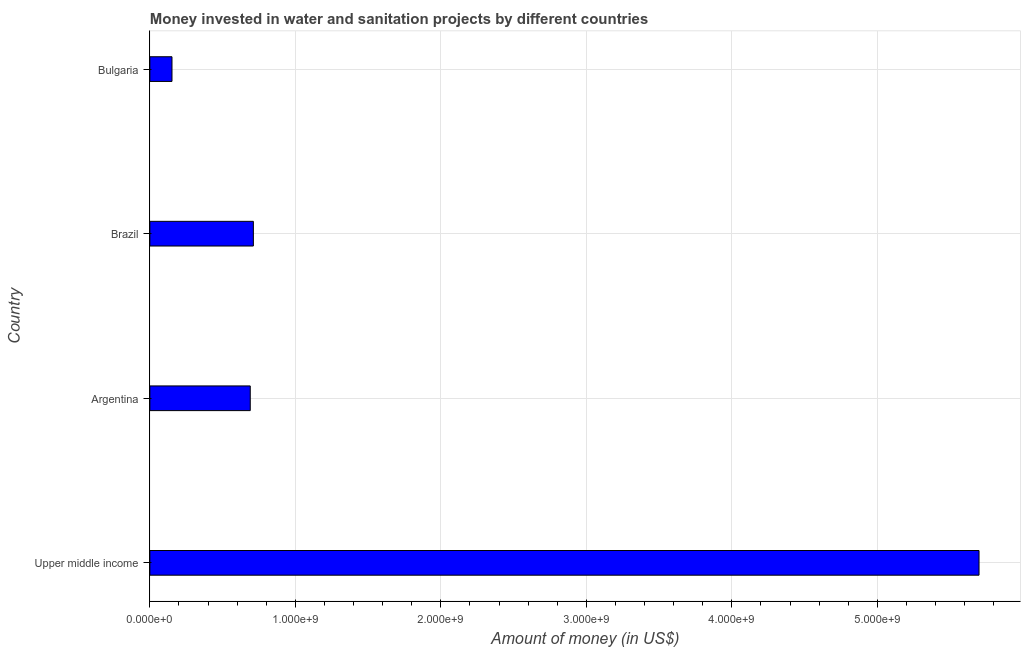Does the graph contain any zero values?
Make the answer very short. No. Does the graph contain grids?
Your answer should be very brief. Yes. What is the title of the graph?
Your answer should be compact. Money invested in water and sanitation projects by different countries. What is the label or title of the X-axis?
Provide a short and direct response. Amount of money (in US$). What is the investment in Brazil?
Keep it short and to the point. 7.11e+08. Across all countries, what is the maximum investment?
Give a very brief answer. 5.70e+09. Across all countries, what is the minimum investment?
Give a very brief answer. 1.52e+08. In which country was the investment maximum?
Your answer should be very brief. Upper middle income. What is the sum of the investment?
Provide a succinct answer. 7.25e+09. What is the difference between the investment in Argentina and Upper middle income?
Your answer should be very brief. -5.01e+09. What is the average investment per country?
Offer a terse response. 1.81e+09. What is the median investment?
Give a very brief answer. 7.01e+08. What is the ratio of the investment in Argentina to that in Bulgaria?
Make the answer very short. 4.54. Is the investment in Bulgaria less than that in Upper middle income?
Your answer should be very brief. Yes. Is the difference between the investment in Brazil and Bulgaria greater than the difference between any two countries?
Offer a terse response. No. What is the difference between the highest and the second highest investment?
Give a very brief answer. 4.99e+09. What is the difference between the highest and the lowest investment?
Offer a terse response. 5.55e+09. In how many countries, is the investment greater than the average investment taken over all countries?
Keep it short and to the point. 1. How many bars are there?
Provide a short and direct response. 4. Are all the bars in the graph horizontal?
Give a very brief answer. Yes. How many countries are there in the graph?
Give a very brief answer. 4. What is the difference between two consecutive major ticks on the X-axis?
Keep it short and to the point. 1.00e+09. What is the Amount of money (in US$) in Upper middle income?
Offer a very short reply. 5.70e+09. What is the Amount of money (in US$) in Argentina?
Your answer should be very brief. 6.90e+08. What is the Amount of money (in US$) in Brazil?
Your response must be concise. 7.11e+08. What is the Amount of money (in US$) in Bulgaria?
Your answer should be very brief. 1.52e+08. What is the difference between the Amount of money (in US$) in Upper middle income and Argentina?
Your answer should be compact. 5.01e+09. What is the difference between the Amount of money (in US$) in Upper middle income and Brazil?
Offer a very short reply. 4.99e+09. What is the difference between the Amount of money (in US$) in Upper middle income and Bulgaria?
Your answer should be very brief. 5.55e+09. What is the difference between the Amount of money (in US$) in Argentina and Brazil?
Provide a succinct answer. -2.14e+07. What is the difference between the Amount of money (in US$) in Argentina and Bulgaria?
Keep it short and to the point. 5.38e+08. What is the difference between the Amount of money (in US$) in Brazil and Bulgaria?
Keep it short and to the point. 5.59e+08. What is the ratio of the Amount of money (in US$) in Upper middle income to that in Argentina?
Ensure brevity in your answer.  8.26. What is the ratio of the Amount of money (in US$) in Upper middle income to that in Brazil?
Keep it short and to the point. 8.01. What is the ratio of the Amount of money (in US$) in Upper middle income to that in Bulgaria?
Your response must be concise. 37.49. What is the ratio of the Amount of money (in US$) in Argentina to that in Bulgaria?
Provide a short and direct response. 4.54. What is the ratio of the Amount of money (in US$) in Brazil to that in Bulgaria?
Your answer should be very brief. 4.68. 